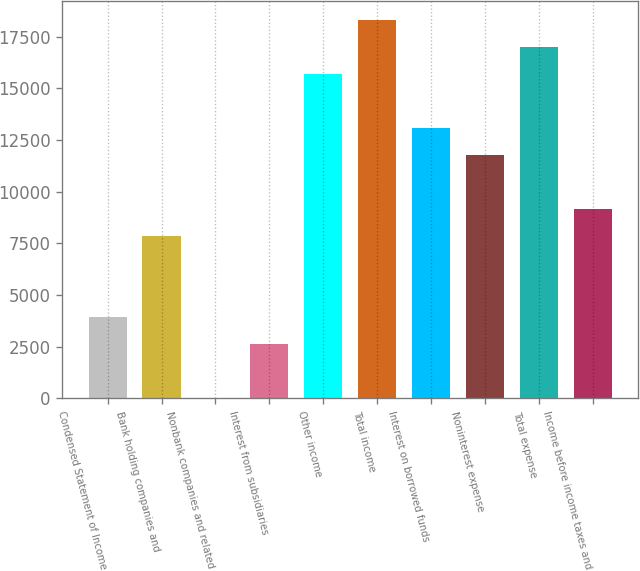Convert chart to OTSL. <chart><loc_0><loc_0><loc_500><loc_500><bar_chart><fcel>Condensed Statement of Income<fcel>Bank holding companies and<fcel>Nonbank companies and related<fcel>Interest from subsidiaries<fcel>Other income<fcel>Total income<fcel>Interest on borrowed funds<fcel>Noninterest expense<fcel>Total expense<fcel>Income before income taxes and<nl><fcel>3945.9<fcel>7864.8<fcel>27<fcel>2639.6<fcel>15702.6<fcel>18315.2<fcel>13090<fcel>11783.7<fcel>17008.9<fcel>9171.1<nl></chart> 